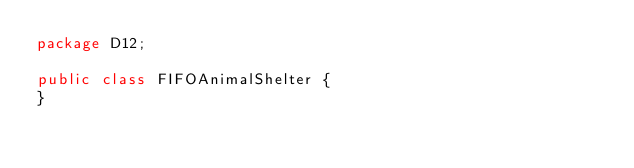<code> <loc_0><loc_0><loc_500><loc_500><_Java_>package D12;

public class FIFOAnimalShelter {
}
</code> 